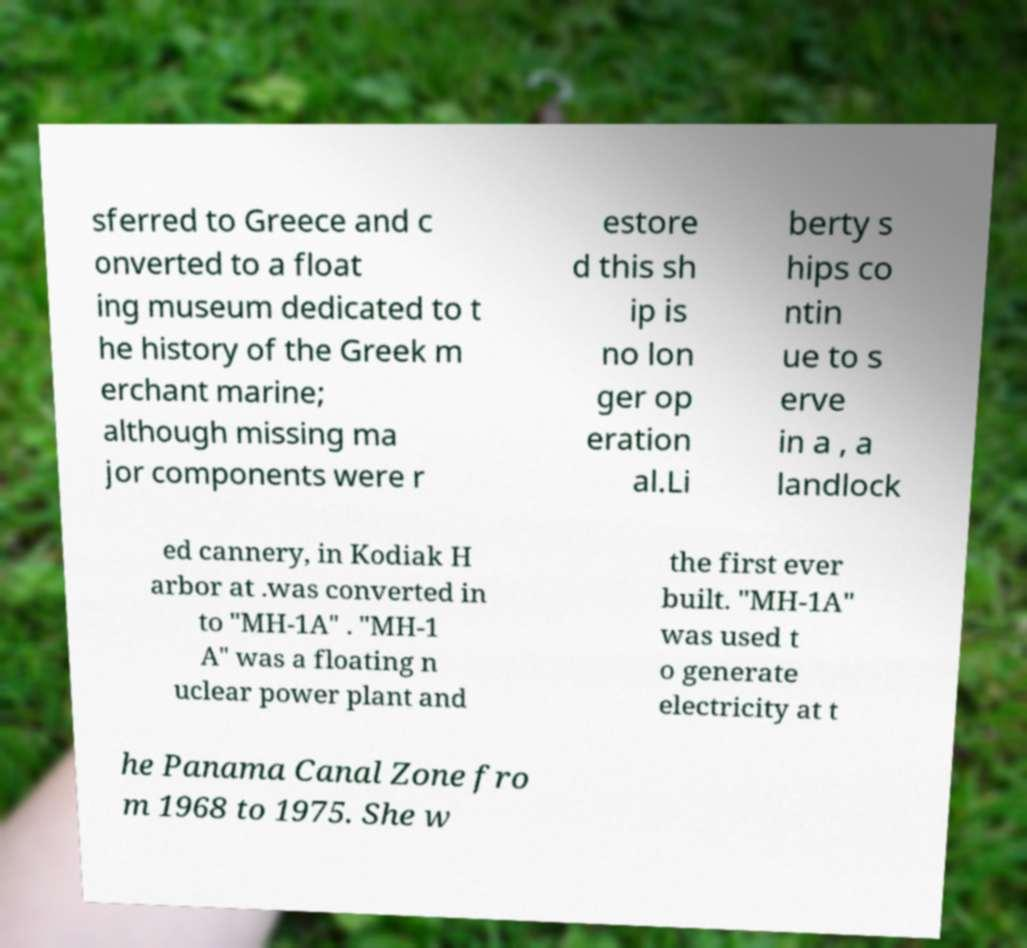There's text embedded in this image that I need extracted. Can you transcribe it verbatim? sferred to Greece and c onverted to a float ing museum dedicated to t he history of the Greek m erchant marine; although missing ma jor components were r estore d this sh ip is no lon ger op eration al.Li berty s hips co ntin ue to s erve in a , a landlock ed cannery, in Kodiak H arbor at .was converted in to "MH-1A" . "MH-1 A" was a floating n uclear power plant and the first ever built. "MH-1A" was used t o generate electricity at t he Panama Canal Zone fro m 1968 to 1975. She w 